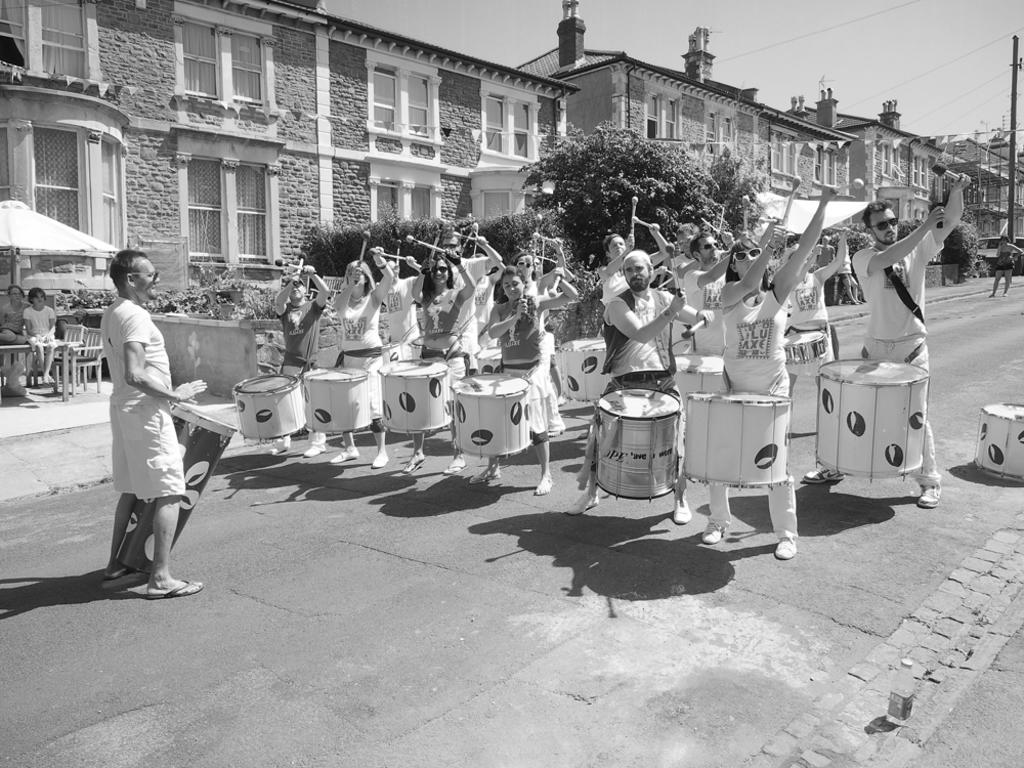What are the people in the image doing? The people in the image are playing the drum set. What can be seen in the background of the image? There are buildings and plants in the background of the image. What type of advertisement can be seen on the drum set in the image? There is no advertisement present on the drum set in the image. 